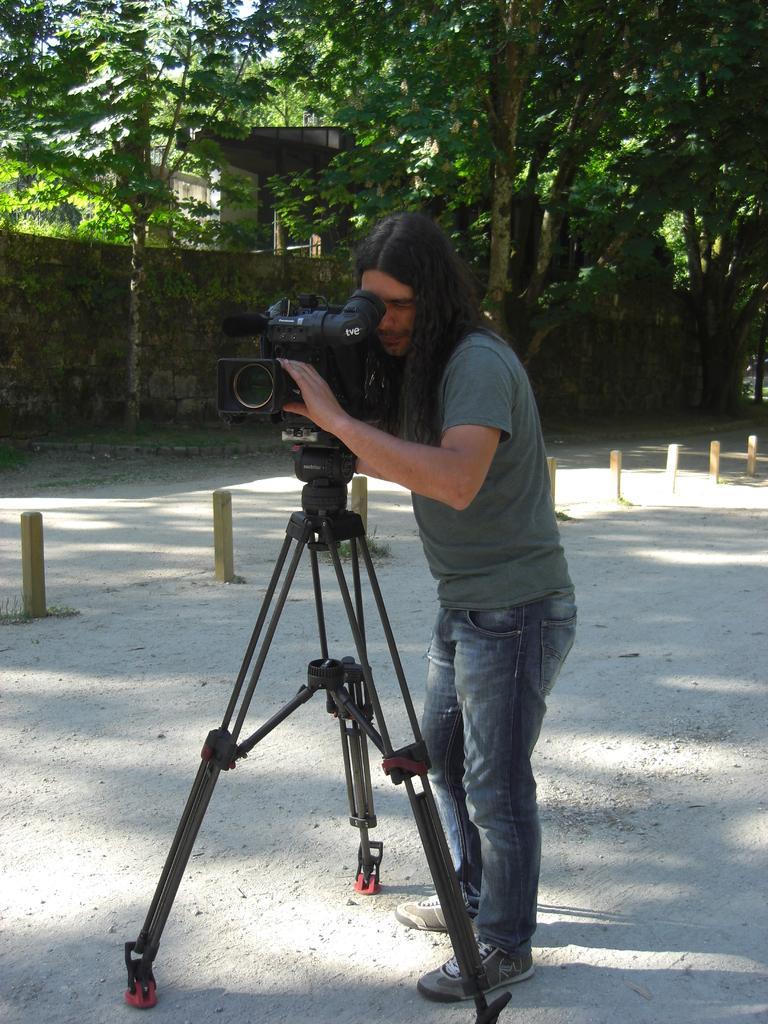Could you give a brief overview of what you see in this image? In this image there is a person standing , there is a camera with a tripod stand , and in the background there is a wall , house, trees. 